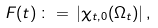<formula> <loc_0><loc_0><loc_500><loc_500>F ( t ) \, \colon = \, | \chi _ { t , 0 } ( \Omega _ { t } ) | \, ,</formula> 